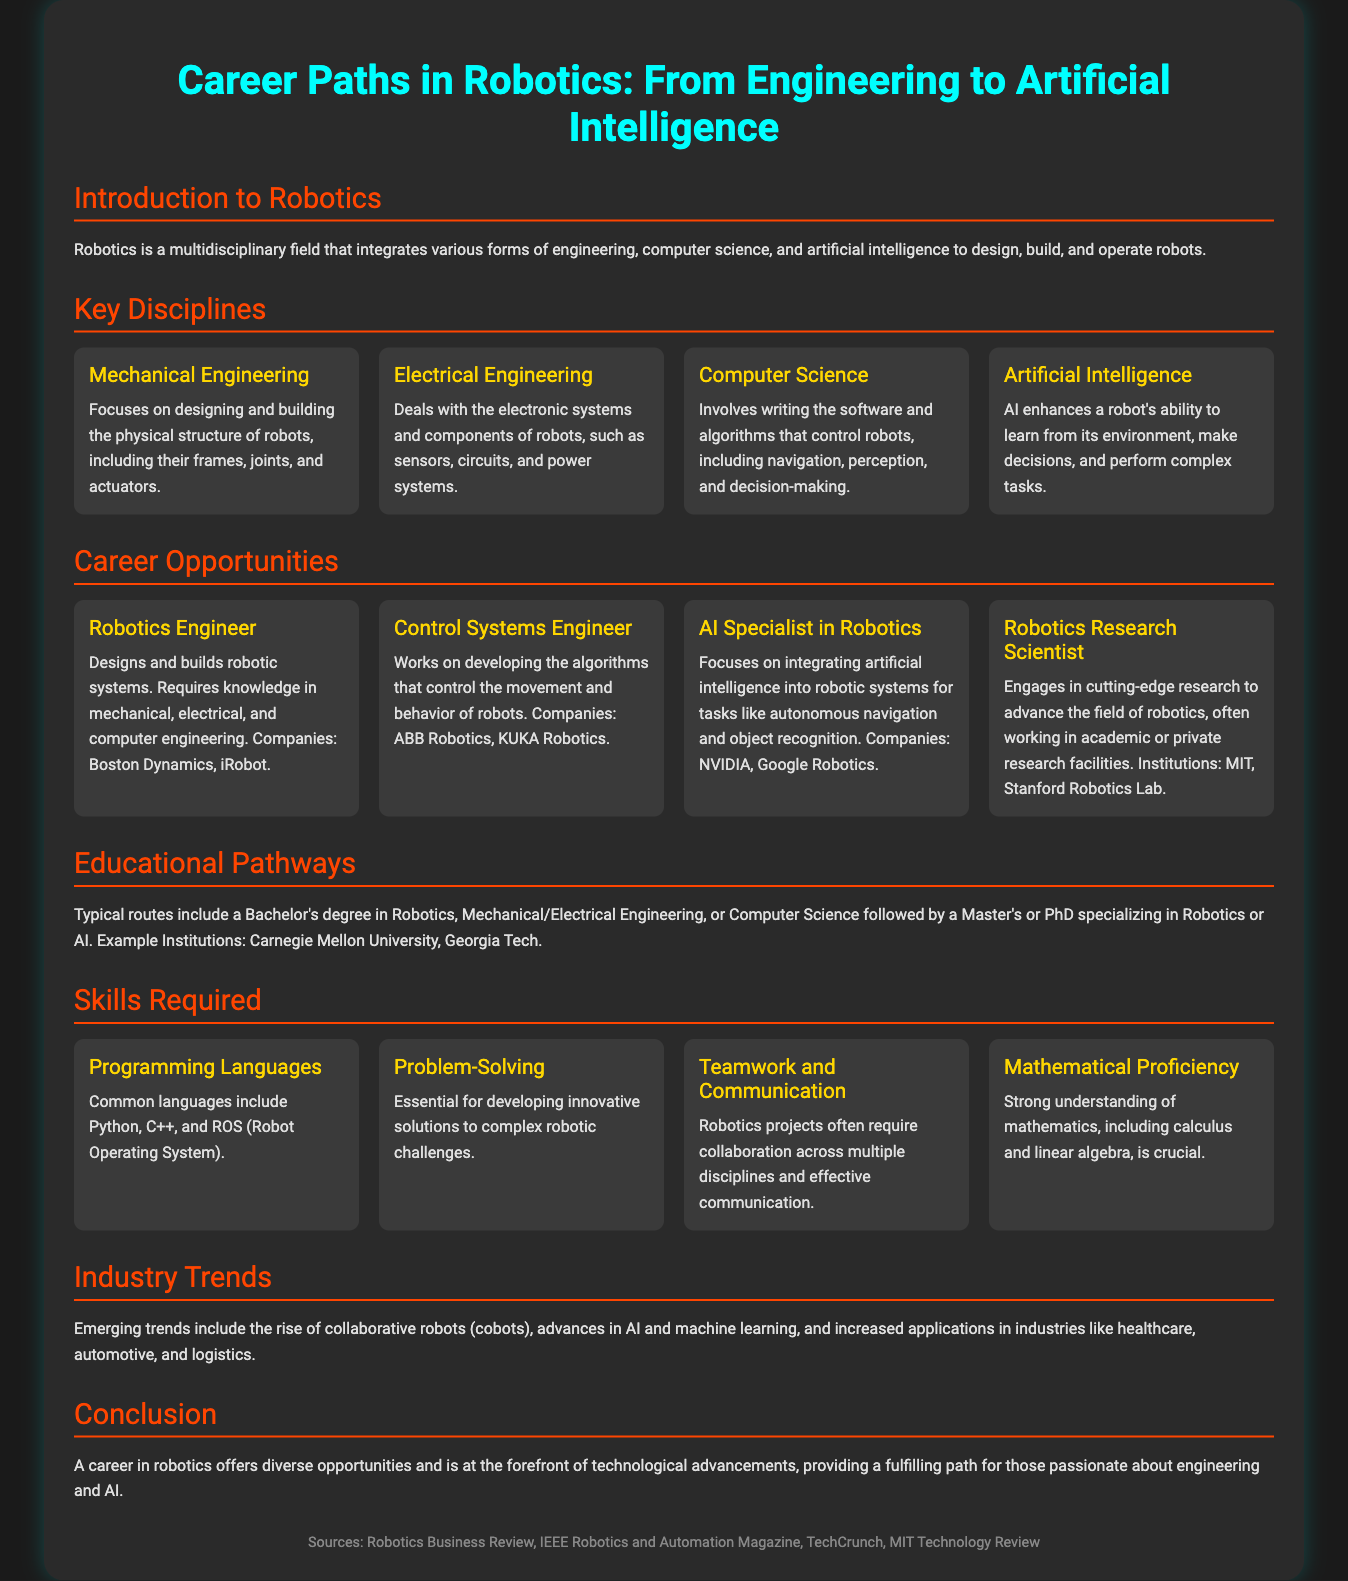what is the main focus of mechanical engineering in robotics? Mechanical engineering focuses on designing and building the physical structure of robots, including their frames, joints, and actuators.
Answer: designing and building which company is mentioned in connection with robotics engineering? The document lists companies that employ robotics engineers including Boston Dynamics and iRobot.
Answer: Boston Dynamics, iRobot what type of degrees are suggested for a career in robotics? The document states typical routes include a Bachelor's degree in Robotics, Mechanical/Electrical Engineering, or Computer Science.
Answer: Bachelor's degree what skill is essential for solving complex robotic challenges? The document highlights that problem-solving is essential for developing innovative solutions to complex robotic challenges.
Answer: problem-solving which emerging trend in robotics involves collaborative robots? The rise of collaborative robots (cobots) is mentioned as an emerging trend in robotics.
Answer: cobots name one institution known for robotics research mentioned in the document. Institutions mentioned in the document for robotics research include MIT and Stanford Robotics Lab.
Answer: MIT how many key disciplines are listed in the document? The document lists four key disciplines in robotics.
Answer: four what is the role of an AI specialist in robotics? The document states an AI Specialist in Robotics focuses on integrating artificial intelligence into robotic systems for tasks like autonomous navigation and object recognition.
Answer: integrating artificial intelligence what is one requirement for becoming a Robotics Engineer? The document notes that a Robotics Engineer requires knowledge in mechanical, electrical, and computer engineering.
Answer: knowledge in engineering 